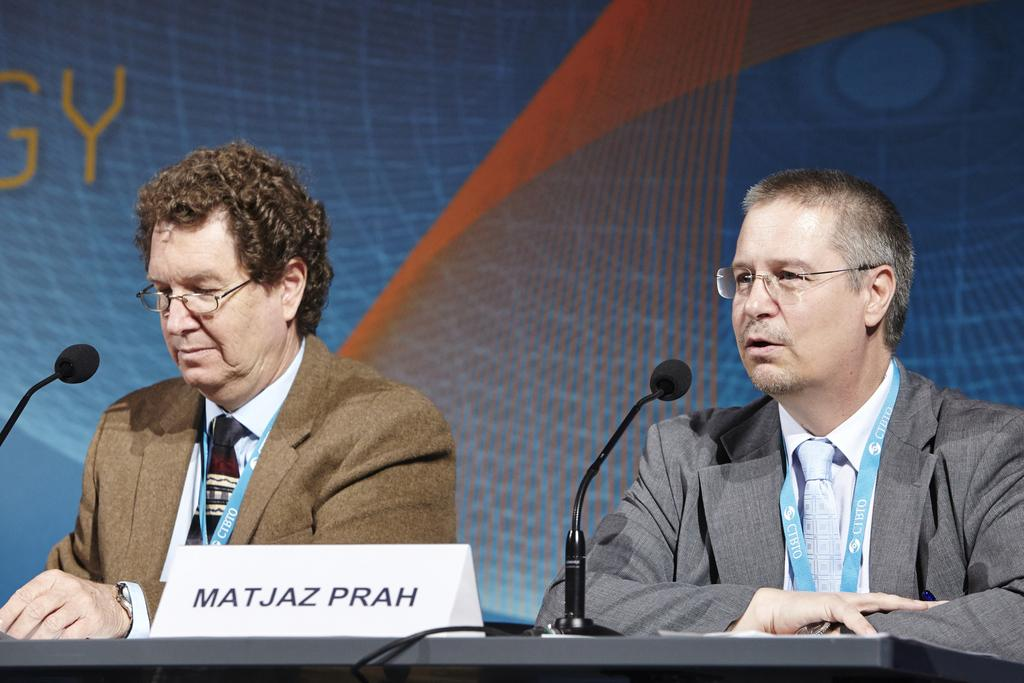How many people are in the image? There are two men in the image. What are the men doing in the image? The men are sitting in front of a desk. What objects can be seen on the desk? There are two microphones and a name board on the desk. What is visible in the background of the image? There appears to be a screen in the background of the image. What type of comfort can be seen in the image? There is no specific comfort item visible in the image. What suggestion is being made by the men in the image? The image does not provide any information about a suggestion being made by the men. 